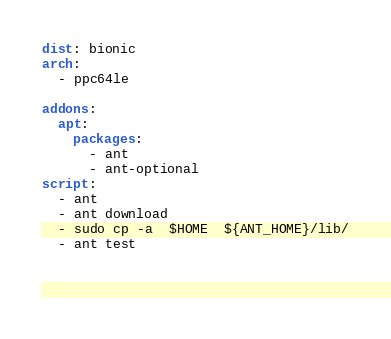<code> <loc_0><loc_0><loc_500><loc_500><_YAML_>dist: bionic
arch:
  - ppc64le
  
addons:
  apt:
    packages:
      - ant
      - ant-optional
script: 
  - ant 
  - ant download
  - sudo cp -a  $HOME  ${ANT_HOME}/lib/
  - ant test
  
  
  
</code> 